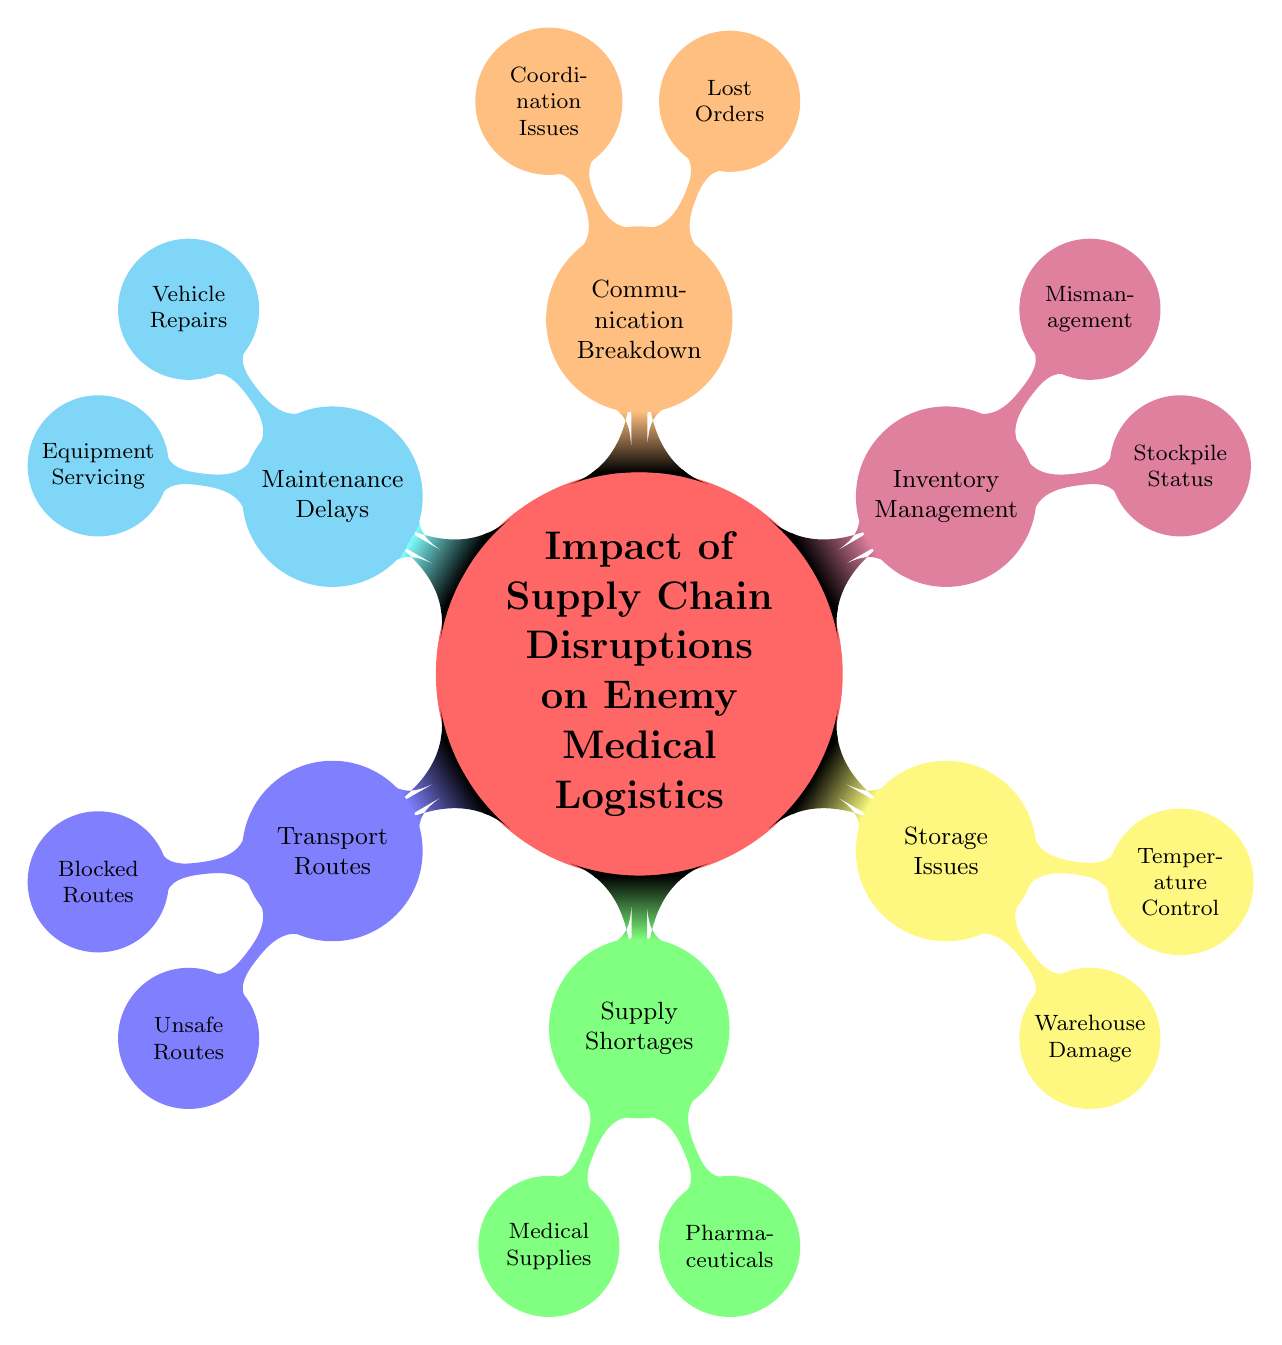What is the primary topic of the diagram? The diagram focuses on the "Impact of Supply Chain Disruptions on Enemy Medical Logistics," which is the main node at the center of the mind map.
Answer: Impact of Supply Chain Disruptions on Enemy Medical Logistics How many main categories are there in the diagram? There are six main categories branching out from the central topic, which are Transport Routes, Supply Shortages, Storage Issues, Inventory Management, Communication Breakdown, and Maintenance Delays.
Answer: 6 What are the two types of issues listed under Supply Shortages? The diagram indicates that the two types of issues under Supply Shortages are Medical Supplies and Pharmaceuticals, which provide further details about the types of shortages.
Answer: Medical Supplies and Pharmaceuticals What is one example of Blocked Routes? The diagram specifies "Bridges destroyed" as an example of Blocked Routes, illustrating a potential transport disruption.
Answer: Bridges destroyed Which category includes "Lack of spare parts"? "Lack of spare parts" is categorized under Maintenance Delays, demonstrating a logistical issue impacting vehicle repairs.
Answer: Maintenance Delays What causes mismanagement in Inventory Management? The diagram states "Improper record-keeping" as the cause of mismanagement within the Inventory Management category, affecting efficiency.
Answer: Improper record-keeping Which child node has the highest impact on medical services according to the diagram? Reasoning through the categories, Supply Shortages would have the highest impact on medical services, as it directly affects the medical supplies needed for treatment.
Answer: Supply Shortages How are Transport Routes affected by IED activity? The diagram indicates that areas with high IED activity are classified as Unsafe Routes, impacting the transport routes for medical logistics.
Answer: Unsafe Routes What event is listed as a reason for Warehouse Damage? The diagram notes "Airstrike impact" as a reason for Warehouse Damage, which indicates a possible threat to storage capabilities.
Answer: Airstrike impact 